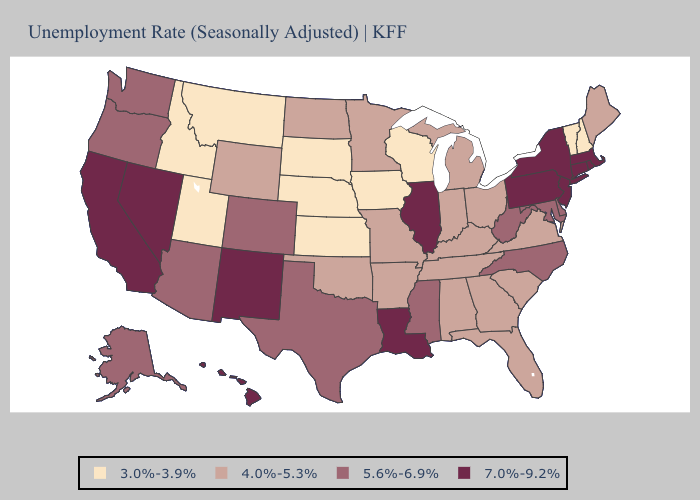How many symbols are there in the legend?
Keep it brief. 4. Does Oklahoma have the highest value in the USA?
Answer briefly. No. Name the states that have a value in the range 4.0%-5.3%?
Answer briefly. Alabama, Arkansas, Florida, Georgia, Indiana, Kentucky, Maine, Michigan, Minnesota, Missouri, North Dakota, Ohio, Oklahoma, South Carolina, Tennessee, Virginia, Wyoming. Name the states that have a value in the range 7.0%-9.2%?
Write a very short answer. California, Connecticut, Hawaii, Illinois, Louisiana, Massachusetts, Nevada, New Jersey, New Mexico, New York, Pennsylvania, Rhode Island. Does Wyoming have a higher value than Oregon?
Give a very brief answer. No. Among the states that border Louisiana , which have the highest value?
Concise answer only. Mississippi, Texas. Name the states that have a value in the range 7.0%-9.2%?
Short answer required. California, Connecticut, Hawaii, Illinois, Louisiana, Massachusetts, Nevada, New Jersey, New Mexico, New York, Pennsylvania, Rhode Island. Which states have the lowest value in the USA?
Concise answer only. Idaho, Iowa, Kansas, Montana, Nebraska, New Hampshire, South Dakota, Utah, Vermont, Wisconsin. Name the states that have a value in the range 4.0%-5.3%?
Concise answer only. Alabama, Arkansas, Florida, Georgia, Indiana, Kentucky, Maine, Michigan, Minnesota, Missouri, North Dakota, Ohio, Oklahoma, South Carolina, Tennessee, Virginia, Wyoming. What is the value of New Jersey?
Write a very short answer. 7.0%-9.2%. What is the highest value in the USA?
Concise answer only. 7.0%-9.2%. Does Michigan have the lowest value in the USA?
Be succinct. No. Among the states that border Colorado , does New Mexico have the highest value?
Be succinct. Yes. Among the states that border New York , does Vermont have the lowest value?
Concise answer only. Yes. What is the lowest value in the USA?
Quick response, please. 3.0%-3.9%. 